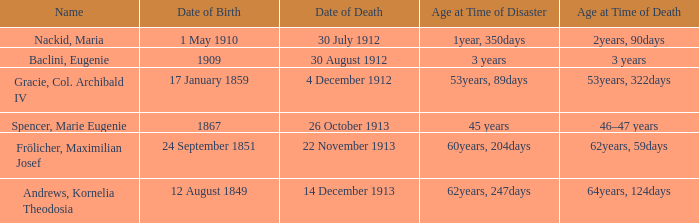How old was the person born 24 September 1851 at the time of disaster? 60years, 204days. 